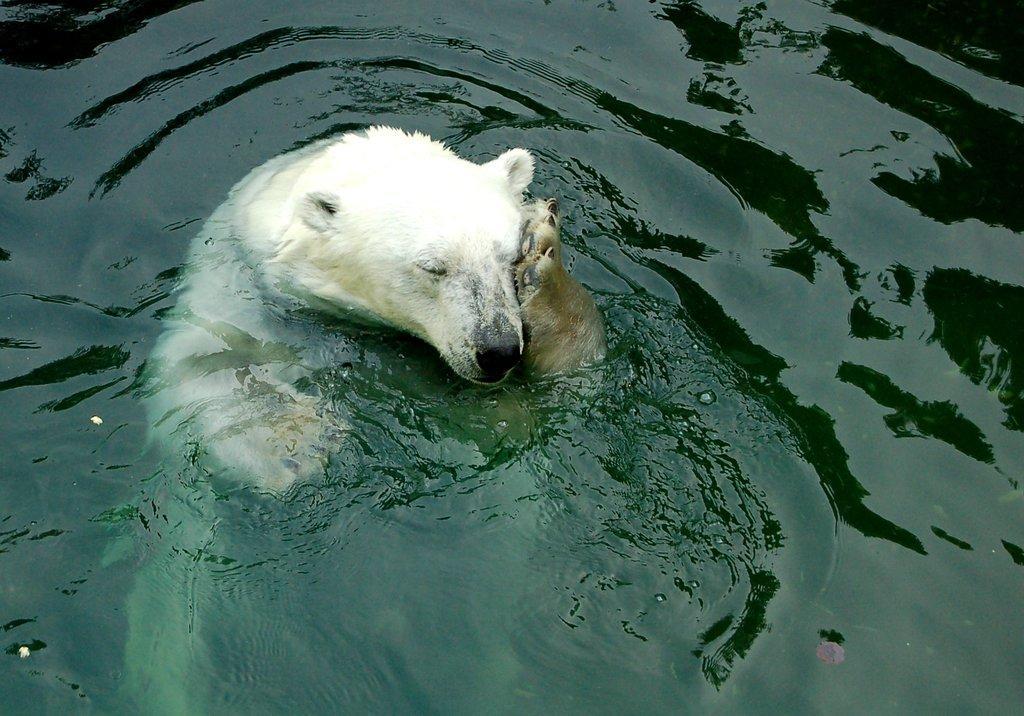Can you describe this image briefly? In this picture there is a polar bear in the water. At the bottom there is water. 